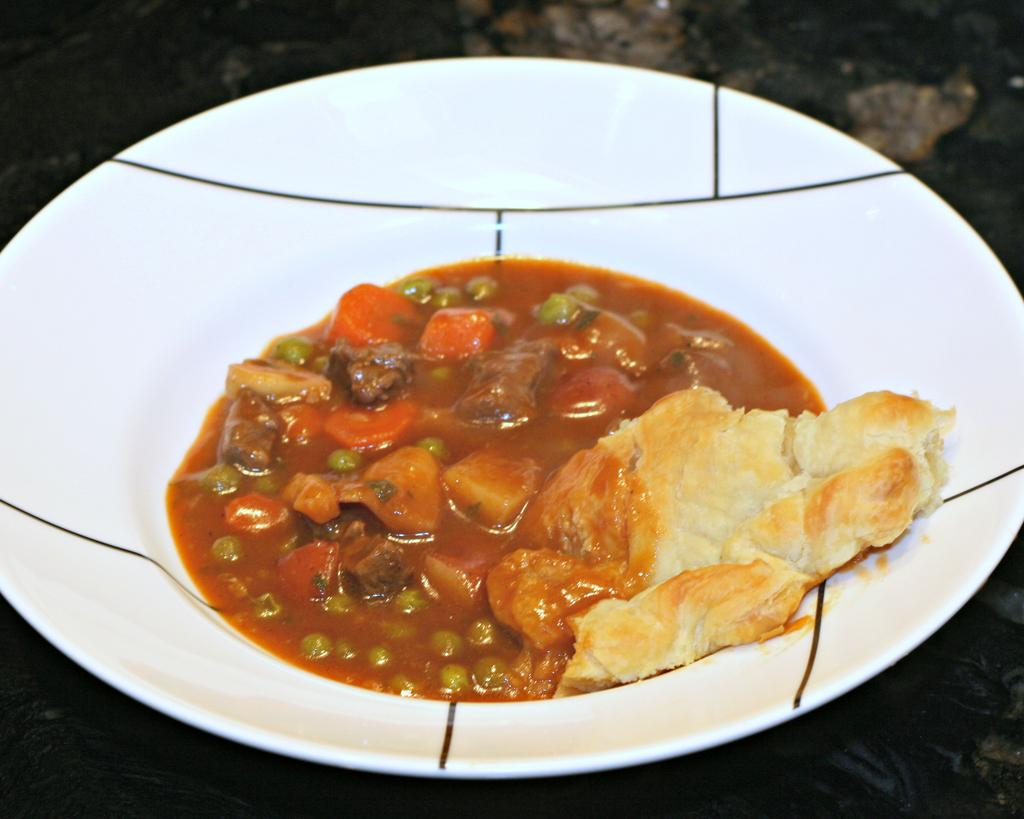What is the main subject of the image? There is a food item in the image. How is the food item presented in the image? The food item is in a plate. Where is the plate with the food item located? The plate is placed on a table. What type of protest is happening in the image? There is no protest present in the image; it features a food item in a plate on a table. Can you tell me what letter the wren is holding in the image? There is no wren or letter present in the image. 